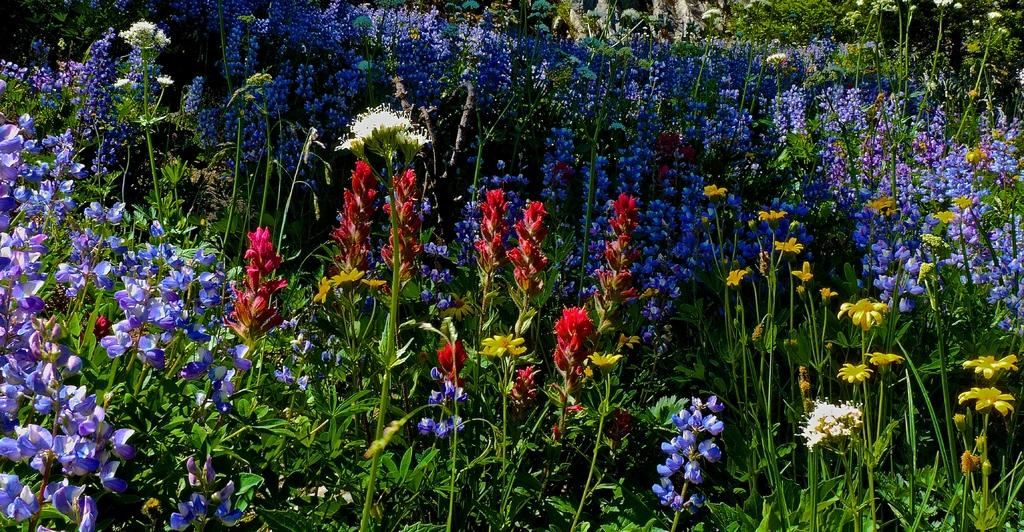What type of living organisms can be seen in the image? Plants and flowers are visible in the image. Can you describe the flowers in the image? The flowers are part of the plants in the image. How many ducks can be seen swimming in the image? There are no ducks present in the image; it features plants and flowers. What type of hen is sitting on the back of the plant in the image? There is no hen present in the image; it only contains plants and flowers. 